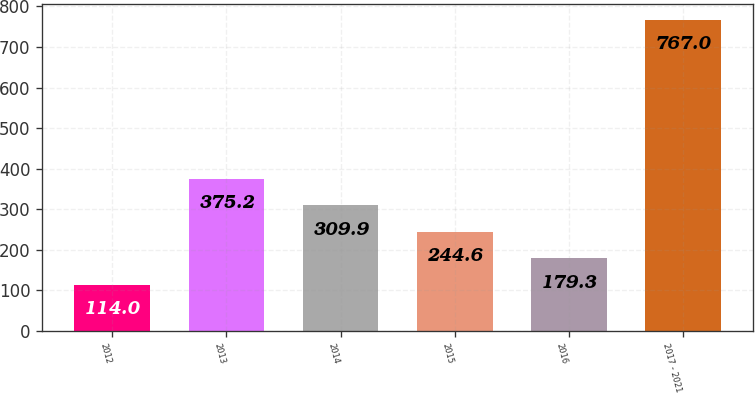Convert chart to OTSL. <chart><loc_0><loc_0><loc_500><loc_500><bar_chart><fcel>2012<fcel>2013<fcel>2014<fcel>2015<fcel>2016<fcel>2017 - 2021<nl><fcel>114<fcel>375.2<fcel>309.9<fcel>244.6<fcel>179.3<fcel>767<nl></chart> 